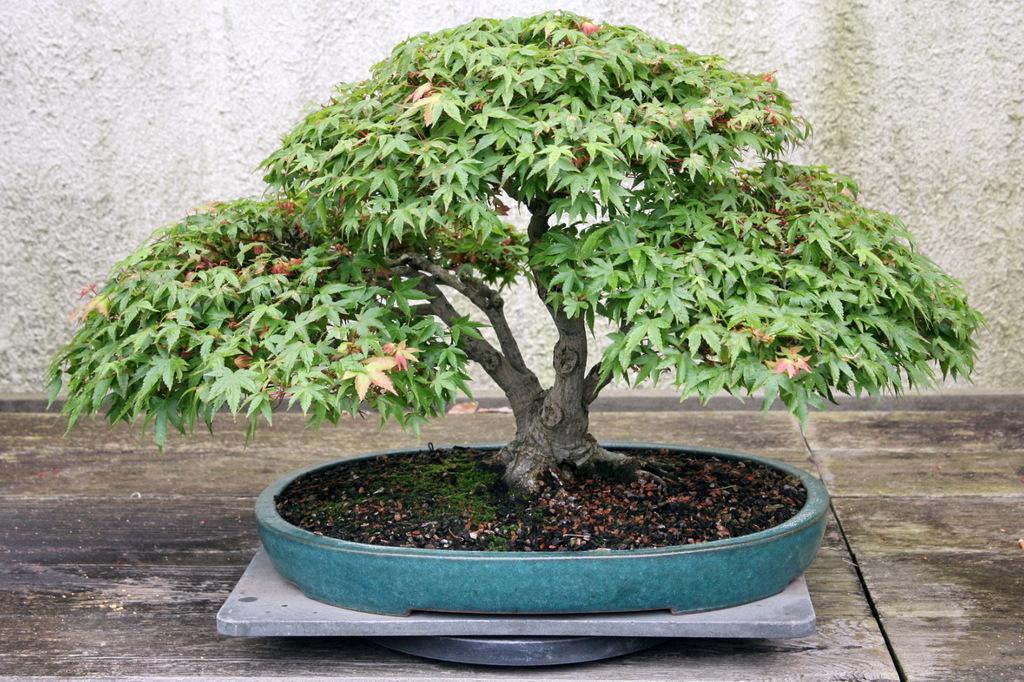Can you describe this image briefly? As we can see in the image there is a pot in which there is a mud and a bonsai is planted and at the back there is a wall which is of white colour and the ground is in wooden ash colour. 